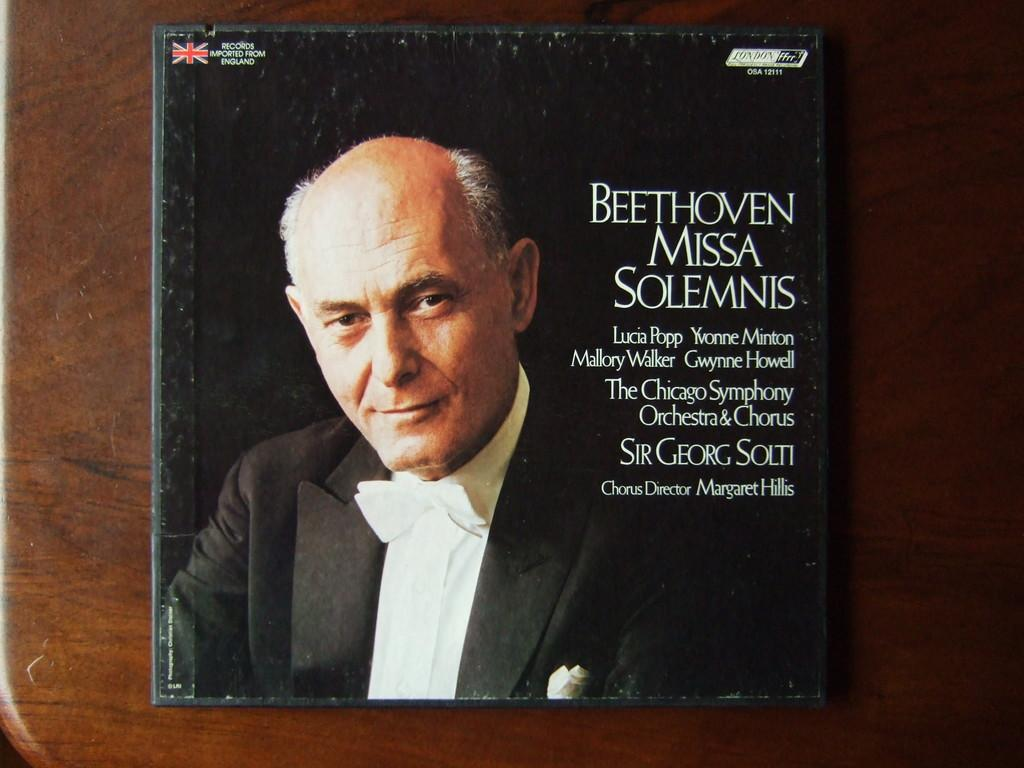<image>
Relay a brief, clear account of the picture shown. cd of beethoven missa solemnis that has an old man in a tuxedo on the cover 